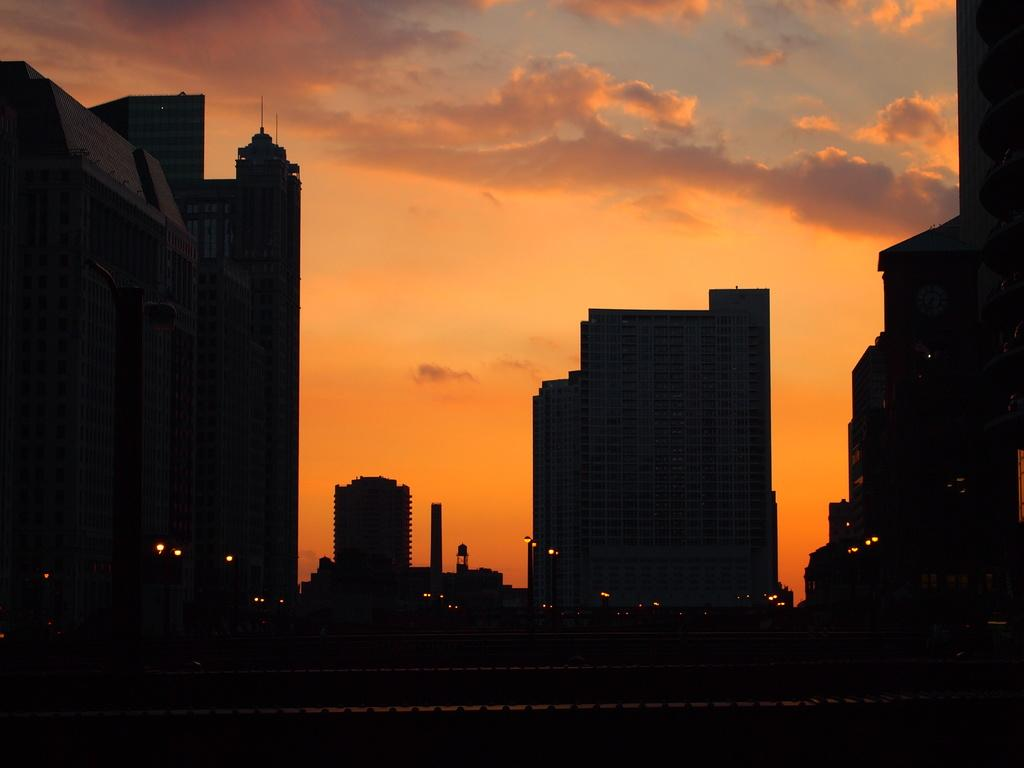What type of man-made structure can be seen in the image? There are buildings in the image. What is the primary mode of transportation visible in the image? There is a road in the image, which suggests that vehicles may be used for transportation. What type of illumination is present in the image? There are lights in the image. What natural element is visible in the background of the image? The sky is visible in the background of the image, and clouds are present in the sky. Are there any giants competing in a disgusting event in the image? No, there are no giants or any events depicted in the image. The image primarily features a road, buildings, lights, and a sky with clouds. 